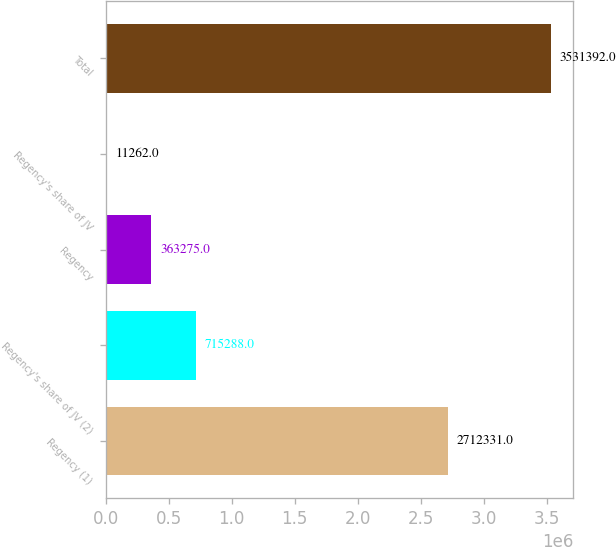<chart> <loc_0><loc_0><loc_500><loc_500><bar_chart><fcel>Regency (1)<fcel>Regency's share of JV (2)<fcel>Regency<fcel>Regency's share of JV<fcel>Total<nl><fcel>2.71233e+06<fcel>715288<fcel>363275<fcel>11262<fcel>3.53139e+06<nl></chart> 